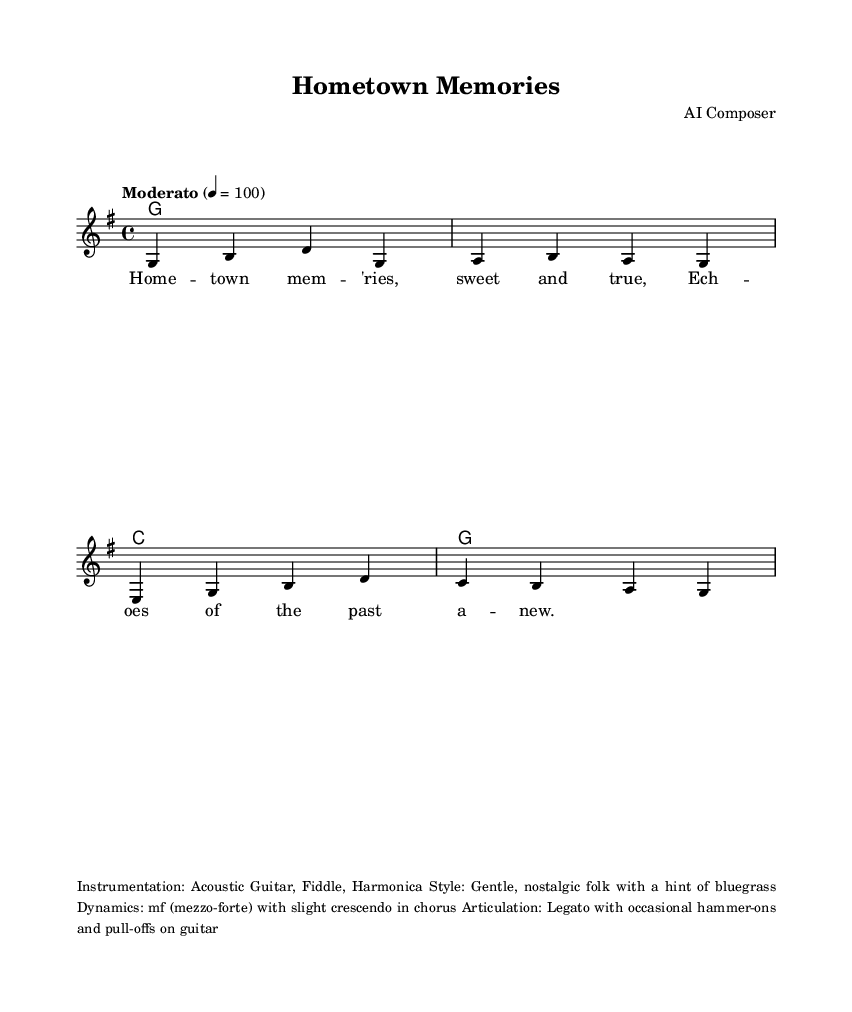What is the key signature of this music? The key signature is G major, which has one sharp (F#).
Answer: G major What is the time signature of this music? The time signature is 4/4, indicating four beats per measure.
Answer: 4/4 What is the tempo marking of this piece? The tempo marking is "Moderato", indicating a moderate speed.
Answer: Moderato What is the instrumentation indicated for this piece? The instrumentation includes Acoustic Guitar, Fiddle, and Harmonica, as noted in the markup section.
Answer: Acoustic Guitar, Fiddle, Harmonica How many measures are in the melody section? The melody has a total of four measures, as indicated by the division of the music.
Answer: Four What is the dynamic marking for the piece? The dynamic marking is mezzo-forte (mf), indicating a moderately loud volume throughout with a slight crescendo in the chorus.
Answer: mf What style is the music classified as? The style is described as gentle, nostalgic folk with a hint of bluegrass, reflecting the mood and instrumentation.
Answer: Gentle, nostalgic folk with a hint of bluegrass 